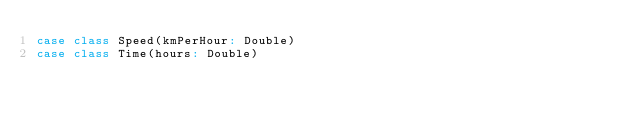Convert code to text. <code><loc_0><loc_0><loc_500><loc_500><_Scala_>case class Speed(kmPerHour: Double)
case class Time(hours: Double)
</code> 